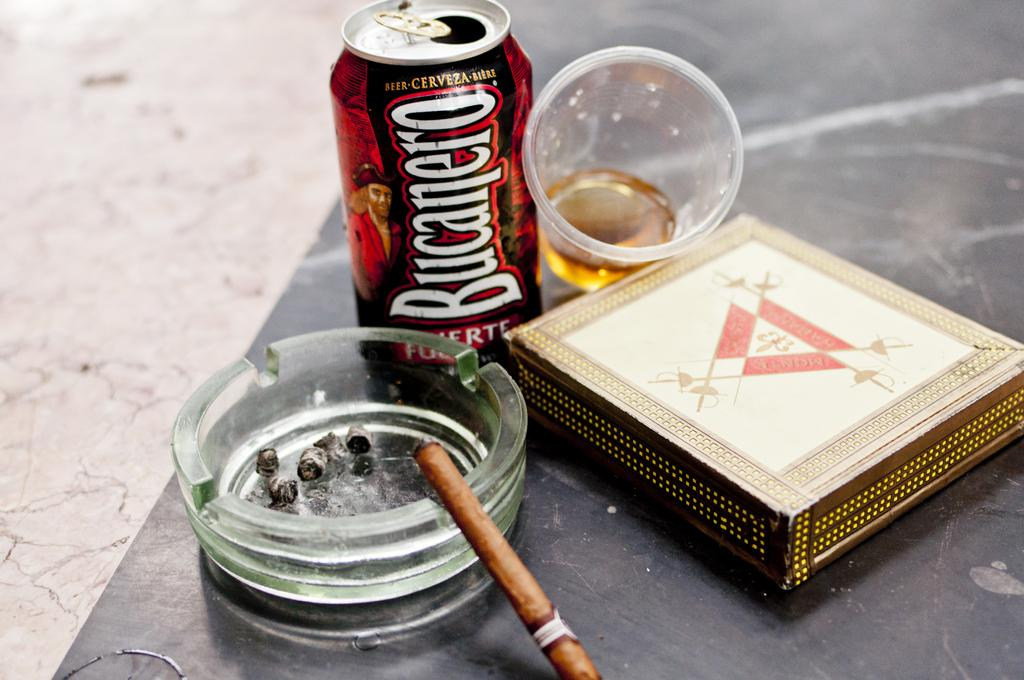<image>
Create a compact narrative representing the image presented. A can of Bucanero sits near an ash tray and a tilted cup. 